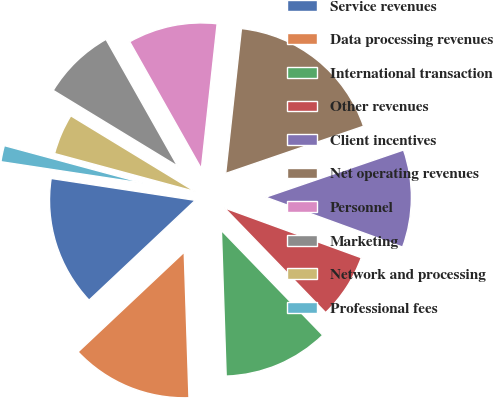Convert chart. <chart><loc_0><loc_0><loc_500><loc_500><pie_chart><fcel>Service revenues<fcel>Data processing revenues<fcel>International transaction<fcel>Other revenues<fcel>Client incentives<fcel>Net operating revenues<fcel>Personnel<fcel>Marketing<fcel>Network and processing<fcel>Professional fees<nl><fcel>14.41%<fcel>13.51%<fcel>11.71%<fcel>7.21%<fcel>10.81%<fcel>18.02%<fcel>9.91%<fcel>8.11%<fcel>4.51%<fcel>1.8%<nl></chart> 